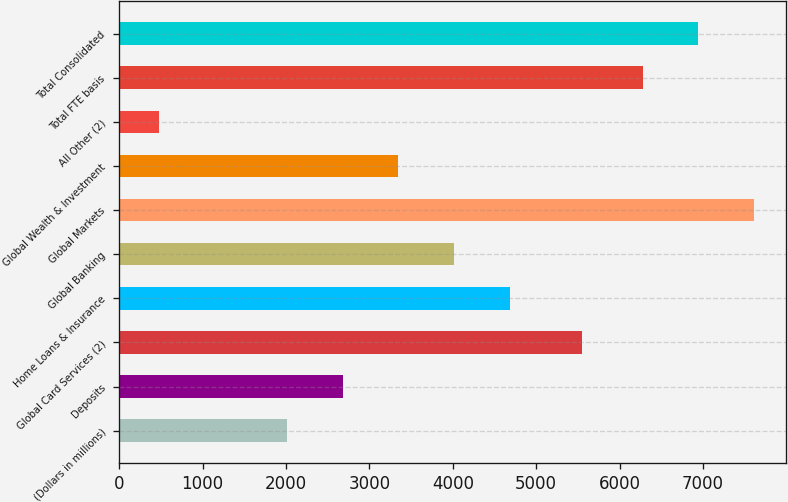<chart> <loc_0><loc_0><loc_500><loc_500><bar_chart><fcel>(Dollars in millions)<fcel>Deposits<fcel>Global Card Services (2)<fcel>Home Loans & Insurance<fcel>Global Banking<fcel>Global Markets<fcel>Global Wealth & Investment<fcel>All Other (2)<fcel>Total FTE basis<fcel>Total Consolidated<nl><fcel>2009<fcel>2678.9<fcel>5555<fcel>4688.6<fcel>4018.7<fcel>7615.8<fcel>3348.8<fcel>478<fcel>6276<fcel>6945.9<nl></chart> 